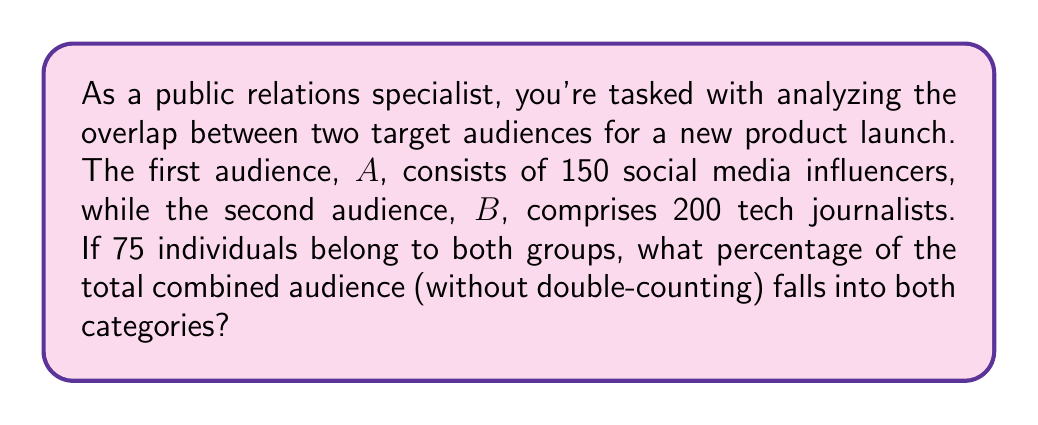Provide a solution to this math problem. To solve this problem, we'll follow these steps:

1) First, let's define our sets:
   $A$ = social media influencers (150 people)
   $B$ = tech journalists (200 people)
   $A \cap B$ = people in both groups (75 people)

2) We need to find the total combined audience without double-counting. This is the union of sets $A$ and $B$, denoted as $A \cup B$. We can calculate this using the formula:

   $$|A \cup B| = |A| + |B| - |A \cap B|$$

   Where $|X|$ denotes the number of elements in set $X$.

3) Let's plug in our values:

   $$|A \cup B| = 150 + 200 - 75 = 275$$

4) Now we know the total combined audience is 275 people.

5) To find the percentage of this audience that falls into both categories, we divide the number in both categories by the total audience and multiply by 100:

   $$\text{Percentage} = \frac{|A \cap B|}{|A \cup B|} \times 100 = \frac{75}{275} \times 100 \approx 27.27\%$$
Answer: Approximately 27.27% of the total combined audience falls into both categories. 